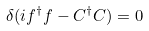<formula> <loc_0><loc_0><loc_500><loc_500>\delta ( i f ^ { \dag } f - C ^ { \dag } C ) = 0</formula> 